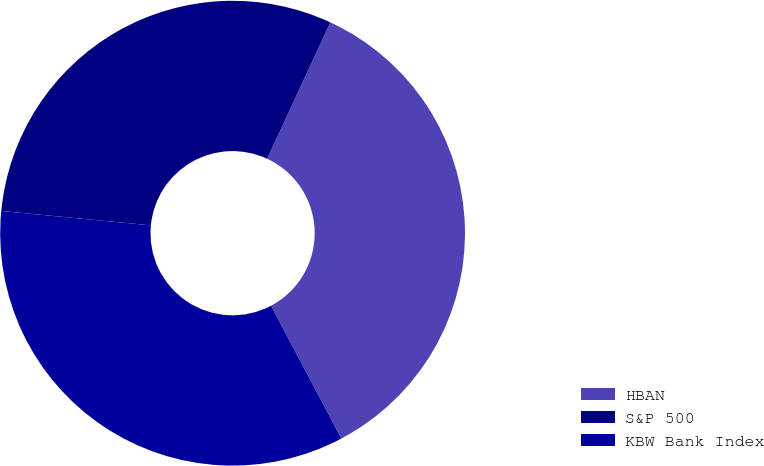Convert chart. <chart><loc_0><loc_0><loc_500><loc_500><pie_chart><fcel>HBAN<fcel>S&P 500<fcel>KBW Bank Index<nl><fcel>35.34%<fcel>30.39%<fcel>34.28%<nl></chart> 